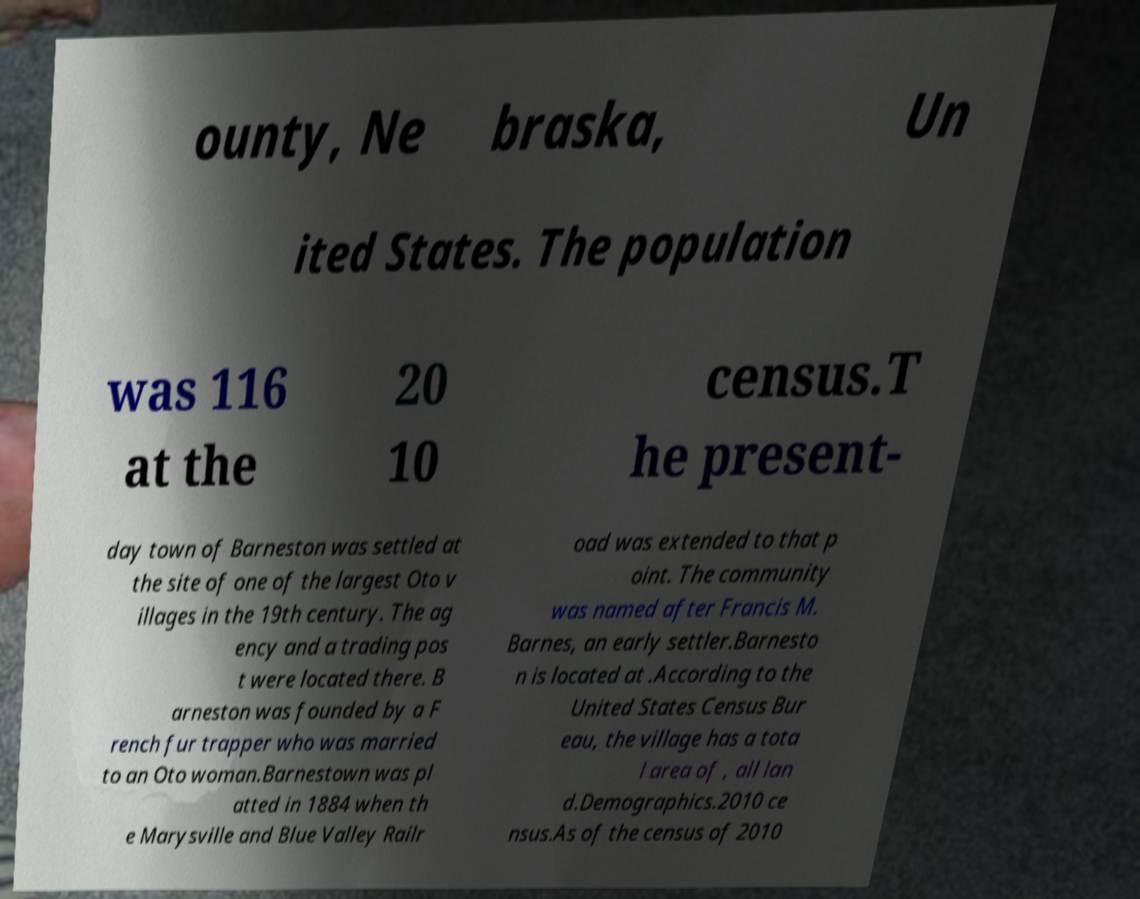What messages or text are displayed in this image? I need them in a readable, typed format. ounty, Ne braska, Un ited States. The population was 116 at the 20 10 census.T he present- day town of Barneston was settled at the site of one of the largest Oto v illages in the 19th century. The ag ency and a trading pos t were located there. B arneston was founded by a F rench fur trapper who was married to an Oto woman.Barnestown was pl atted in 1884 when th e Marysville and Blue Valley Railr oad was extended to that p oint. The community was named after Francis M. Barnes, an early settler.Barnesto n is located at .According to the United States Census Bur eau, the village has a tota l area of , all lan d.Demographics.2010 ce nsus.As of the census of 2010 